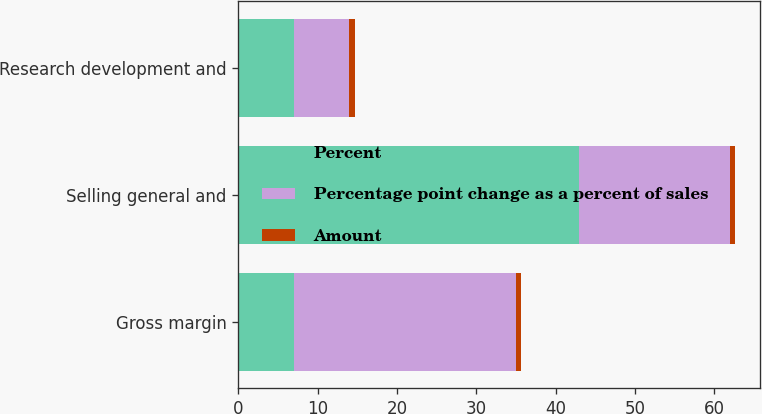Convert chart. <chart><loc_0><loc_0><loc_500><loc_500><stacked_bar_chart><ecel><fcel>Gross margin<fcel>Selling general and<fcel>Research development and<nl><fcel>Percent<fcel>7<fcel>43<fcel>7<nl><fcel>Percentage point change as a percent of sales<fcel>28<fcel>19<fcel>7<nl><fcel>Amount<fcel>0.6<fcel>0.6<fcel>0.7<nl></chart> 